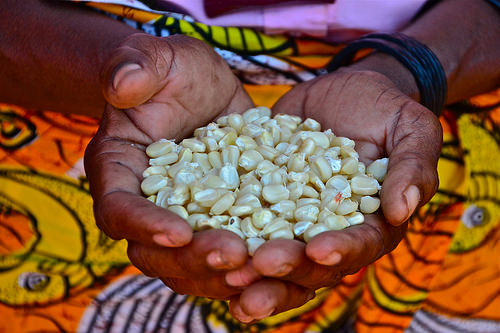<image>
Can you confirm if the corn is next to the hands? No. The corn is not positioned next to the hands. They are located in different areas of the scene. 